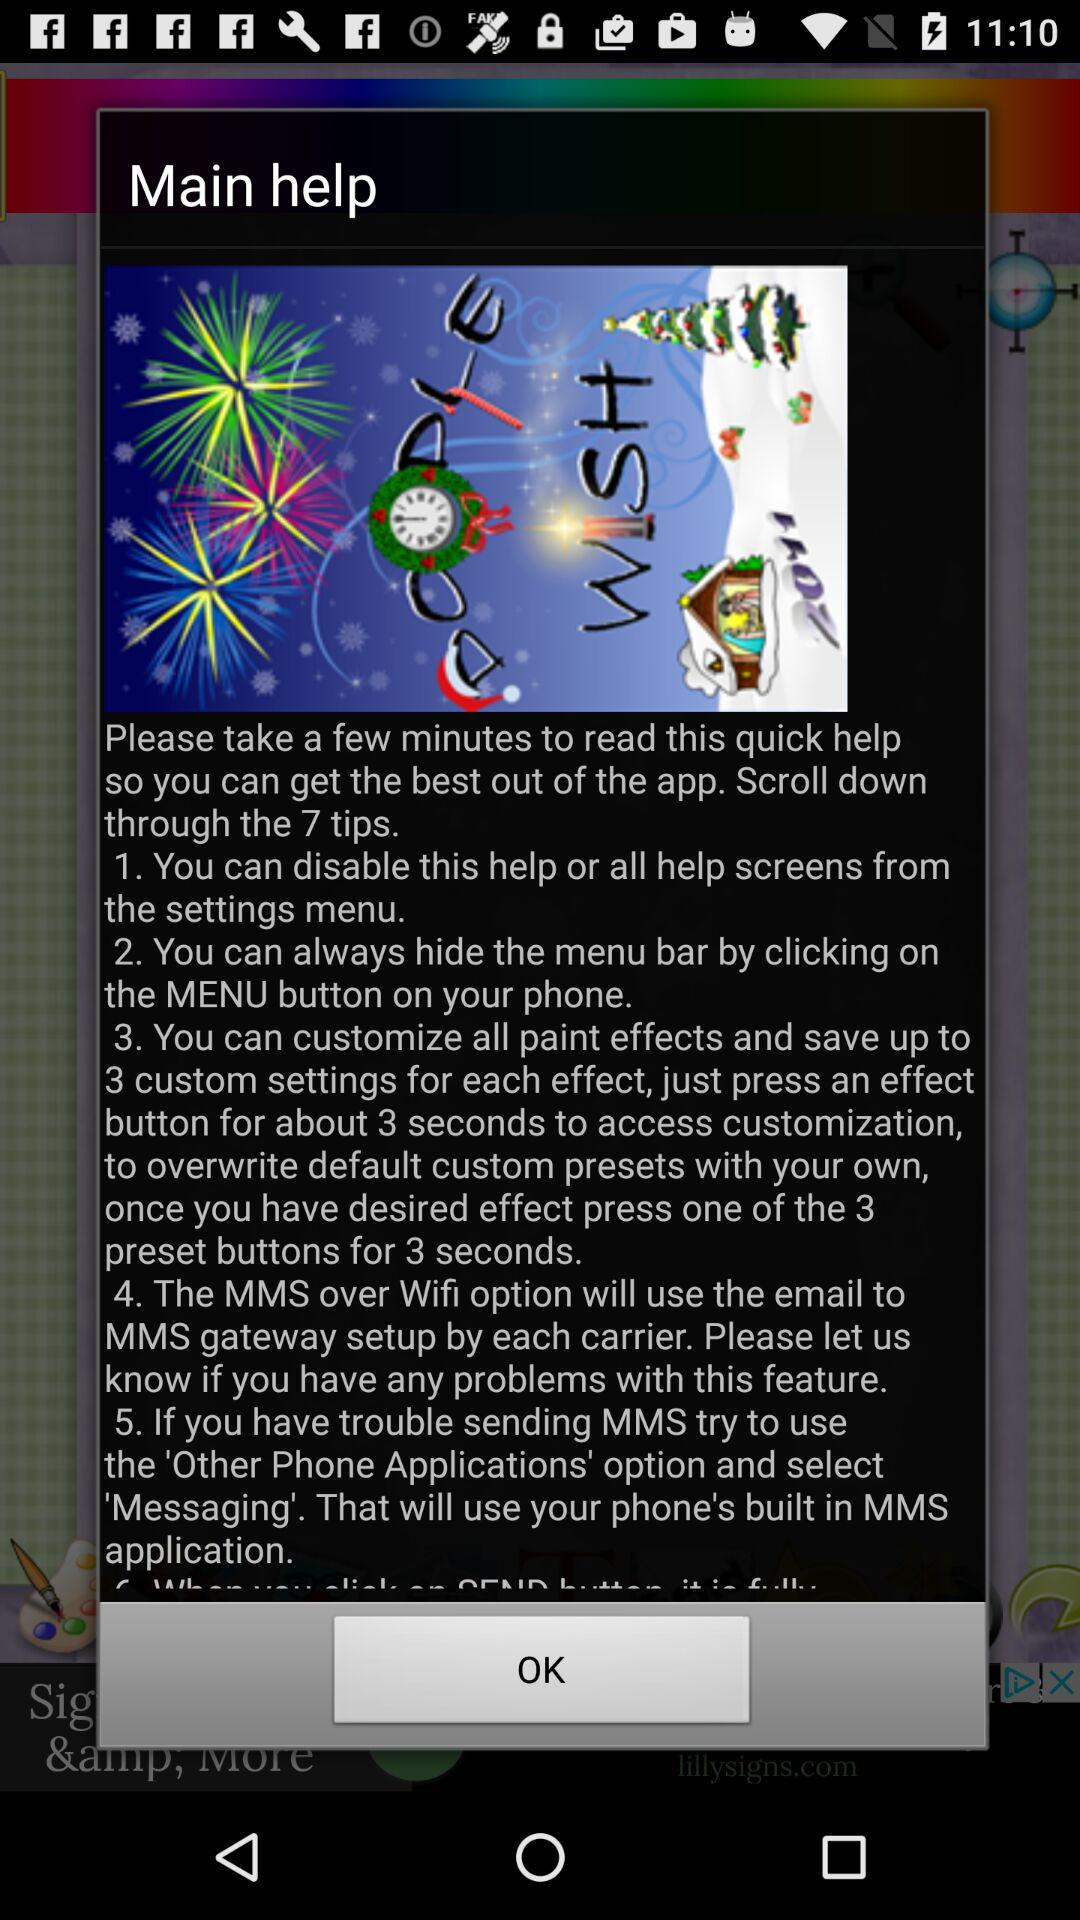How many tips in total are there? There are 7 tips in total. 